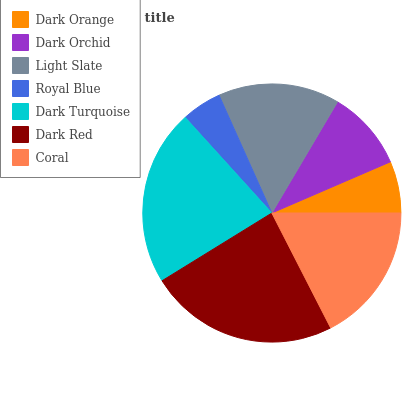Is Royal Blue the minimum?
Answer yes or no. Yes. Is Dark Red the maximum?
Answer yes or no. Yes. Is Dark Orchid the minimum?
Answer yes or no. No. Is Dark Orchid the maximum?
Answer yes or no. No. Is Dark Orchid greater than Dark Orange?
Answer yes or no. Yes. Is Dark Orange less than Dark Orchid?
Answer yes or no. Yes. Is Dark Orange greater than Dark Orchid?
Answer yes or no. No. Is Dark Orchid less than Dark Orange?
Answer yes or no. No. Is Light Slate the high median?
Answer yes or no. Yes. Is Light Slate the low median?
Answer yes or no. Yes. Is Dark Red the high median?
Answer yes or no. No. Is Dark Orchid the low median?
Answer yes or no. No. 